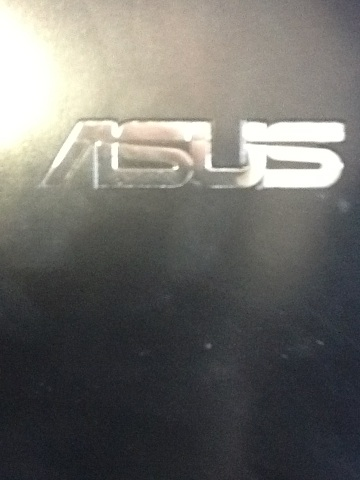If this logo were part of a laptop, list some features of a high-end laptop from this brand. If this logo were part of a high-end Asus laptop, it might include features such as:
- A powerful Intel Core i9 or AMD Ryzen 9 processor
- Up to 32GB of RAM for smooth multitasking
- A 4K OLED display for stunning visuals
- A dedicated NVIDIA RTX 3080 GPU for high-end gaming and graphics work
- Fast storage options like a 1TB NVMe SSD
- Advanced cooling solutions to maintain performance under heavy loads
- Thunderbolt 4 ports for fast data transfer and connectivity
- A backlit RGB keyboard customizable through software
- A large battery offering up to 12 hours of usage on a single charge
- Build quality featuring durable, lightweight materials like magnesium alloy. 